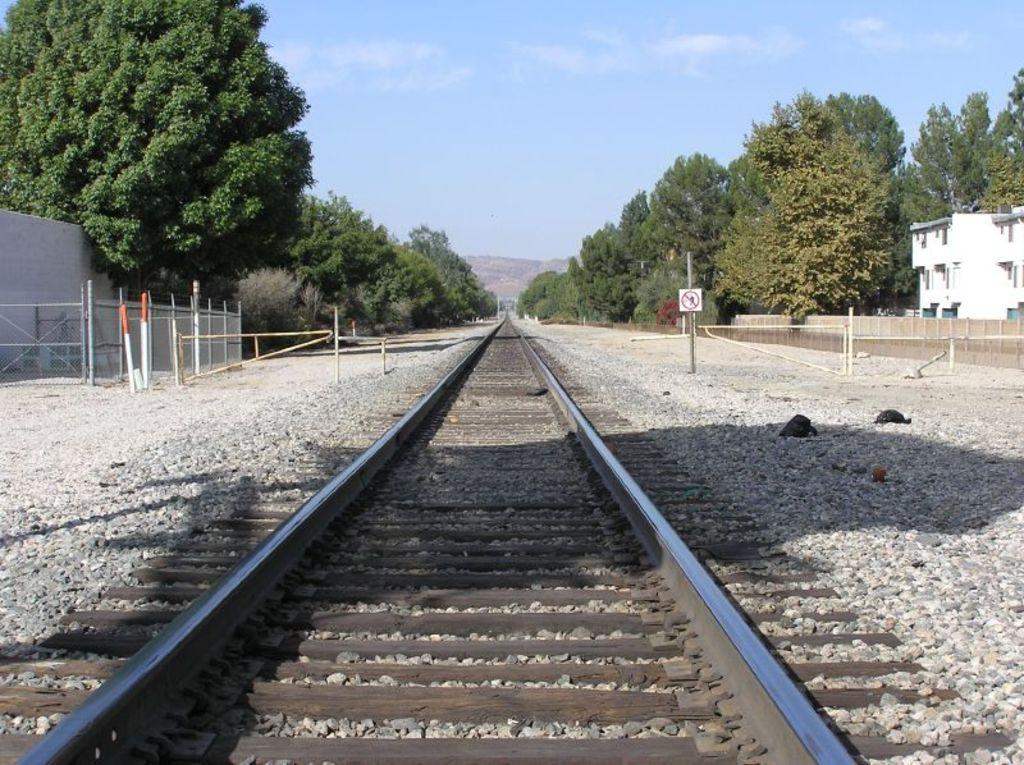What type of vegetation can be seen in the image? There are trees in the image. What type of transportation infrastructure is present in the image? There is a railway track in the image. How would you describe the sky in the image? The sky is blue and cloudy in the image. What type of structures can be seen in the image? There are buildings visible in the image. What type of signage is present in the image? There are sign boards on poles in the image. What type of ground surface is visible in the image? There are stones on the ground in the image. What type of substance is being spread by the women in the image? There are no women present in the image, and therefore no substance is being spread. What type of emotion is being expressed by the women in the image? There are no women present in the image, and therefore no emotion can be observed. 